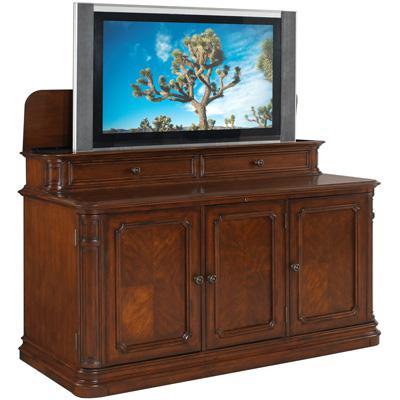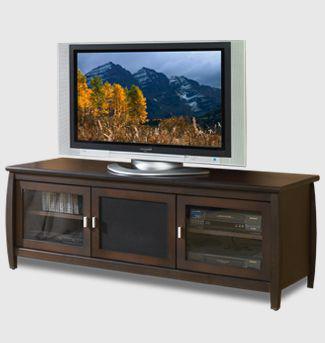The first image is the image on the left, the second image is the image on the right. Analyze the images presented: Is the assertion "All televisions are large tube screens in wooden cabinets." valid? Answer yes or no. No. 